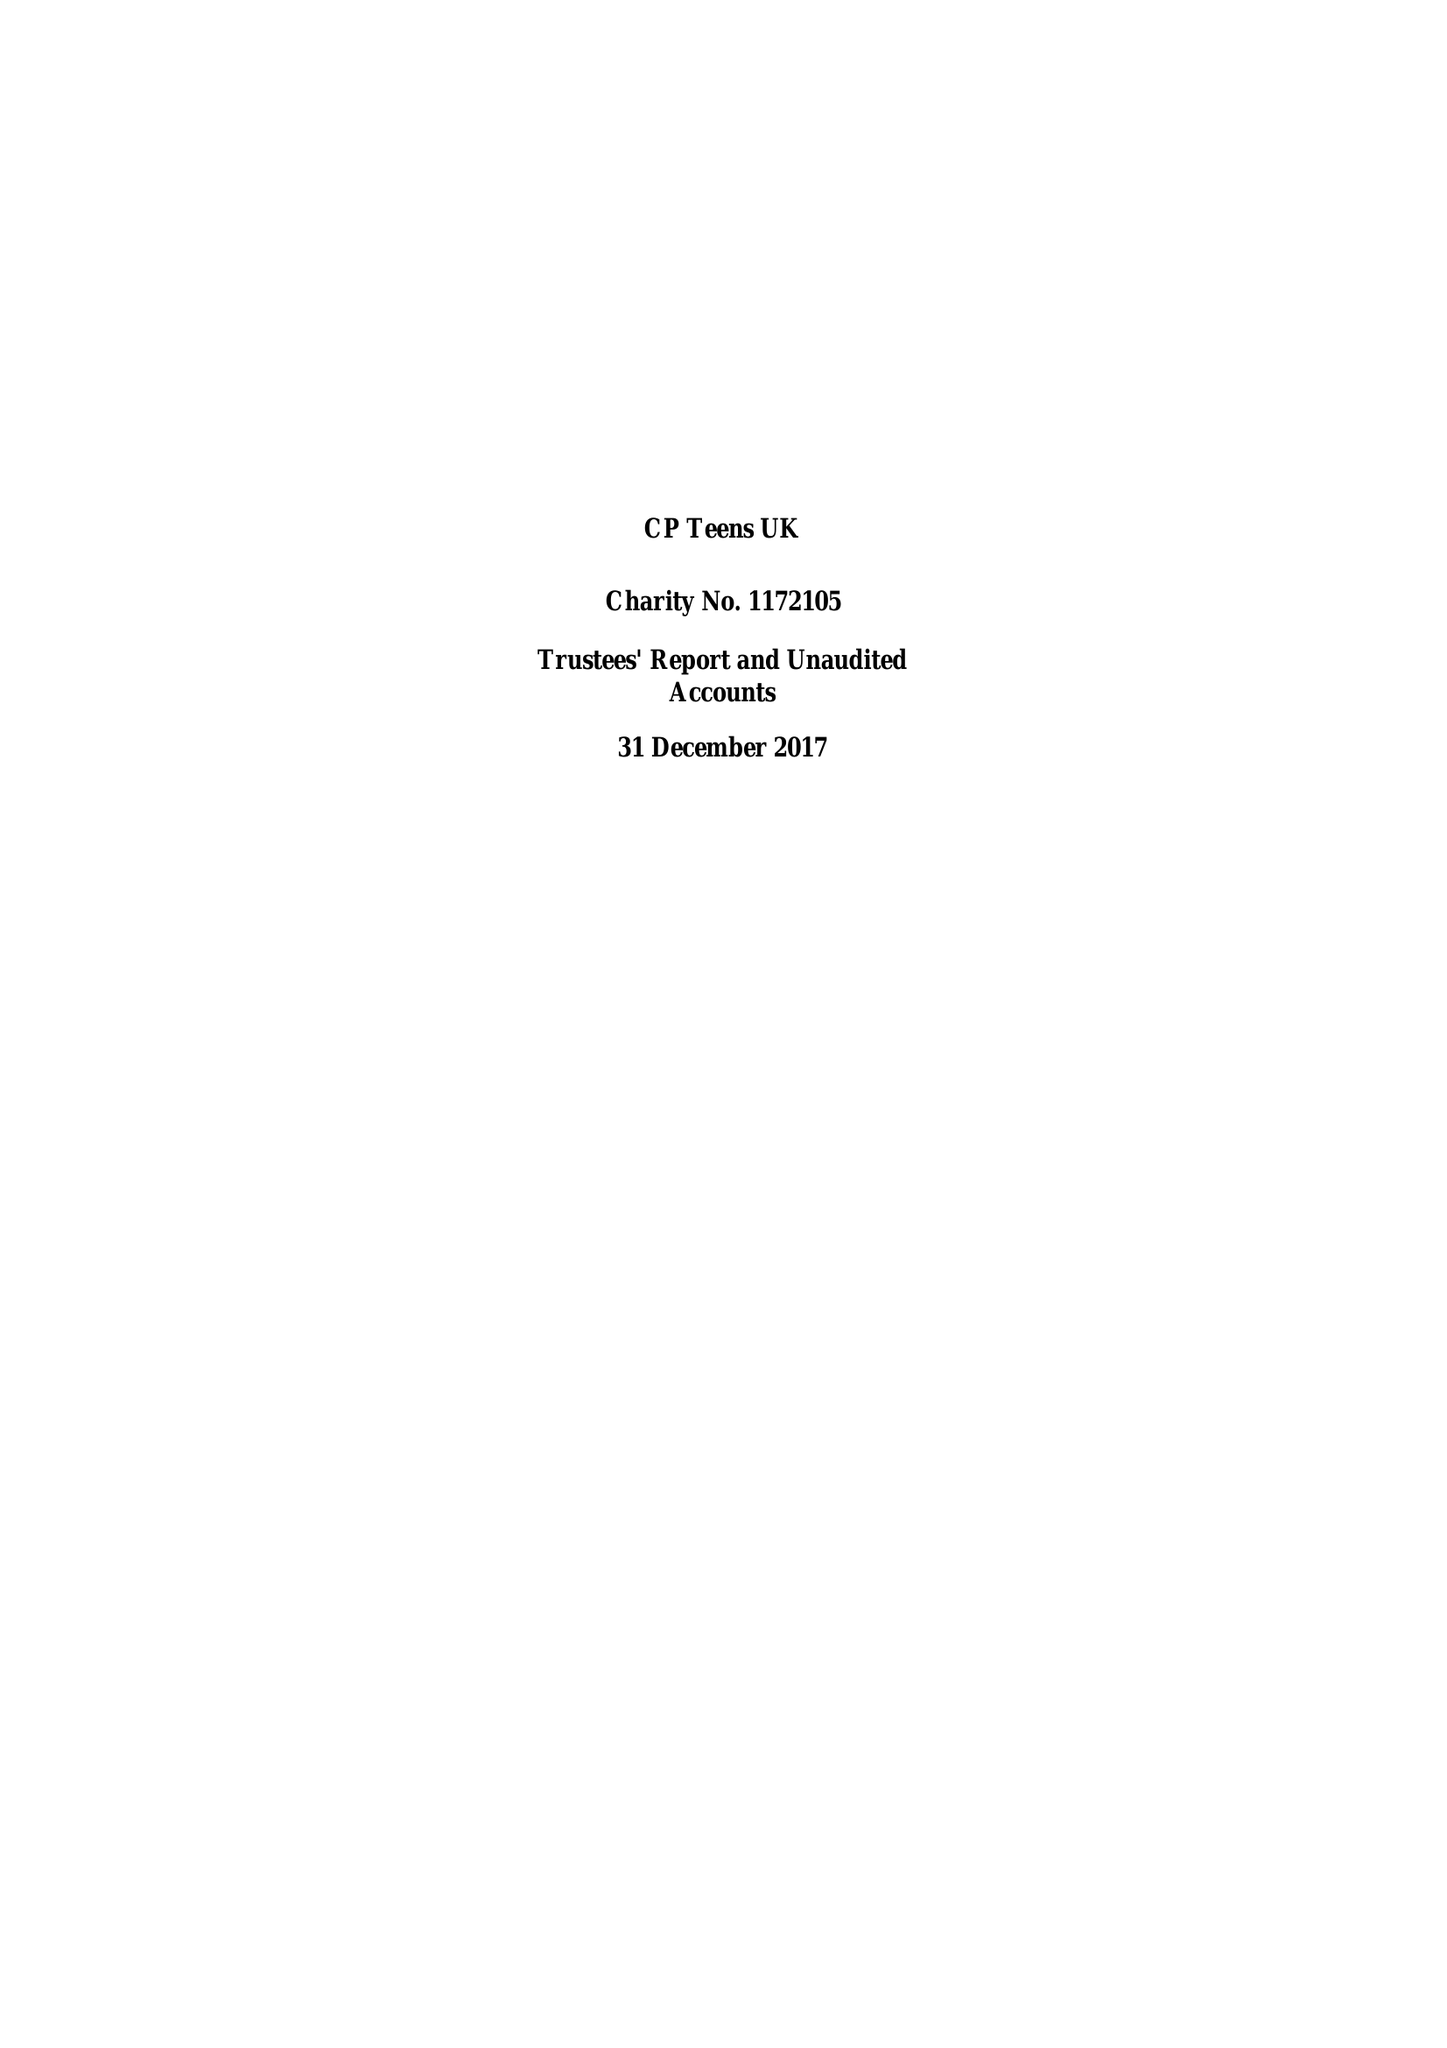What is the value for the report_date?
Answer the question using a single word or phrase. 2017-12-31 